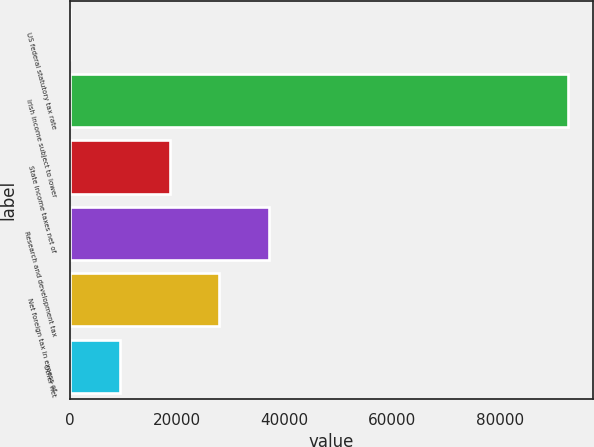Convert chart to OTSL. <chart><loc_0><loc_0><loc_500><loc_500><bar_chart><fcel>US federal statutory tax rate<fcel>Irish income subject to lower<fcel>State income taxes net of<fcel>Research and development tax<fcel>Net foreign tax in excess of<fcel>Other net<nl><fcel>35<fcel>92732<fcel>18574.4<fcel>37113.8<fcel>27844.1<fcel>9304.7<nl></chart> 